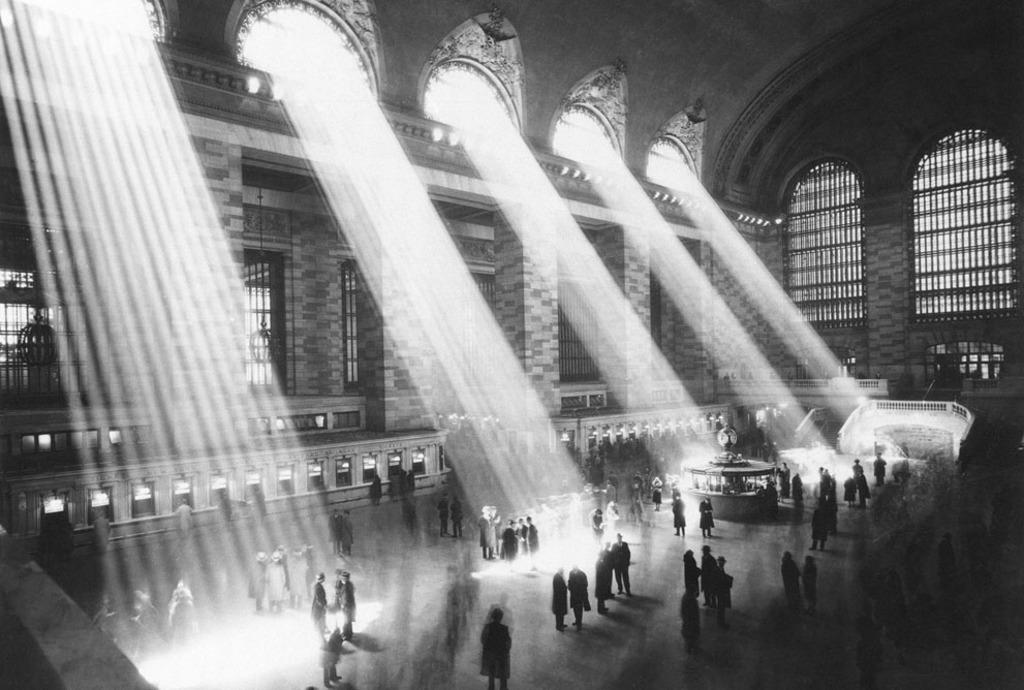What is happening in the room in the image? There are persons standing in a room. What are some features of the room? There are doors, windows, ventilators, and stairs in the room. What type of toe is visible in the image? There is no toe visible in the image; it features persons standing in a room with various features. 